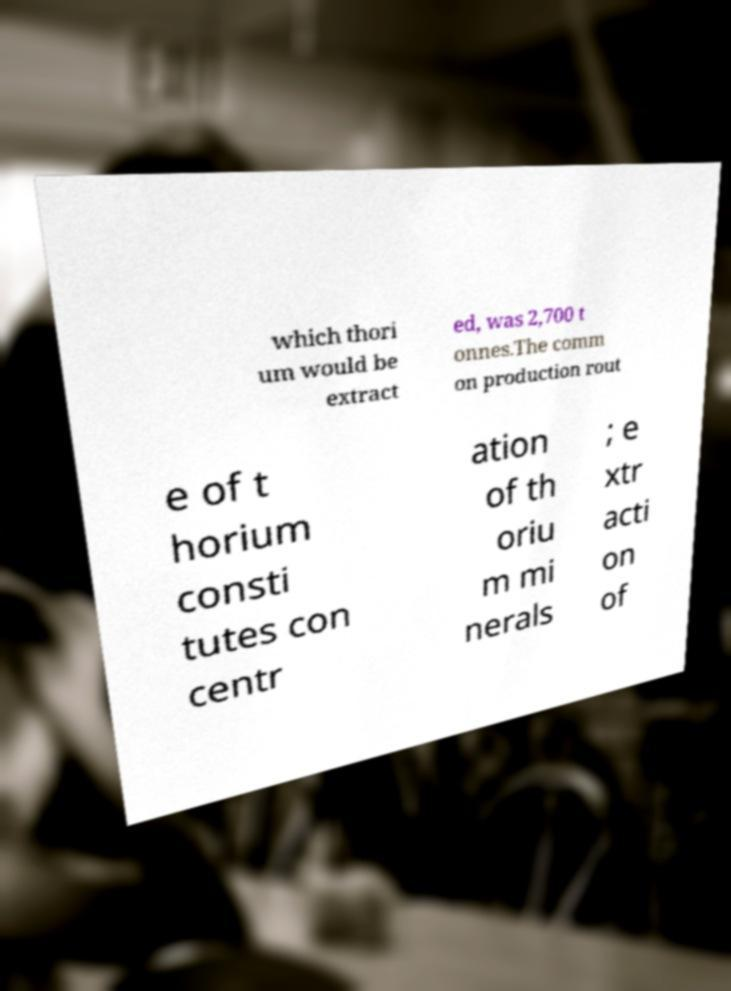Could you assist in decoding the text presented in this image and type it out clearly? which thori um would be extract ed, was 2,700 t onnes.The comm on production rout e of t horium consti tutes con centr ation of th oriu m mi nerals ; e xtr acti on of 